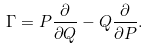Convert formula to latex. <formula><loc_0><loc_0><loc_500><loc_500>\Gamma = P \frac { \partial } { \partial Q } - Q \frac { \partial } { \partial P } .</formula> 